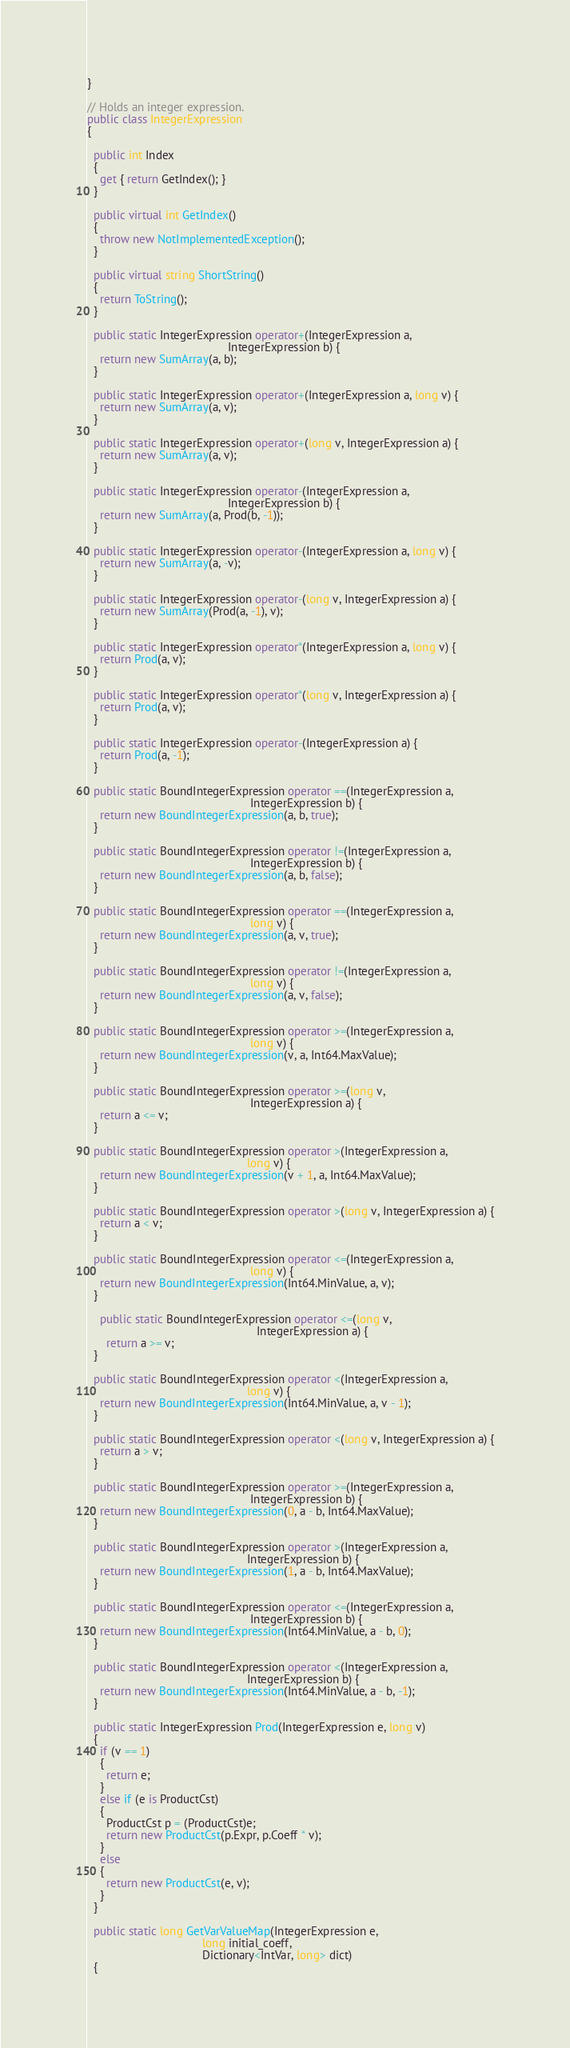Convert code to text. <code><loc_0><loc_0><loc_500><loc_500><_C#_>}

// Holds an integer expression.
public class IntegerExpression
{

  public int Index
  {
    get { return GetIndex(); }
  }

  public virtual int GetIndex()
  {
    throw new NotImplementedException();
  }

  public virtual string ShortString()
  {
    return ToString();
  }

  public static IntegerExpression operator+(IntegerExpression a,
                                            IntegerExpression b) {
    return new SumArray(a, b);
  }

  public static IntegerExpression operator+(IntegerExpression a, long v) {
    return new SumArray(a, v);
  }

  public static IntegerExpression operator+(long v, IntegerExpression a) {
    return new SumArray(a, v);
  }

  public static IntegerExpression operator-(IntegerExpression a,
                                            IntegerExpression b) {
    return new SumArray(a, Prod(b, -1));
  }

  public static IntegerExpression operator-(IntegerExpression a, long v) {
    return new SumArray(a, -v);
  }

  public static IntegerExpression operator-(long v, IntegerExpression a) {
    return new SumArray(Prod(a, -1), v);
  }

  public static IntegerExpression operator*(IntegerExpression a, long v) {
    return Prod(a, v);
  }

  public static IntegerExpression operator*(long v, IntegerExpression a) {
    return Prod(a, v);
  }

  public static IntegerExpression operator-(IntegerExpression a) {
    return Prod(a, -1);
  }

  public static BoundIntegerExpression operator ==(IntegerExpression a,
                                                   IntegerExpression b) {
    return new BoundIntegerExpression(a, b, true);
  }

  public static BoundIntegerExpression operator !=(IntegerExpression a,
                                                   IntegerExpression b) {
    return new BoundIntegerExpression(a, b, false);
  }

  public static BoundIntegerExpression operator ==(IntegerExpression a,
                                                   long v) {
    return new BoundIntegerExpression(a, v, true);
  }

  public static BoundIntegerExpression operator !=(IntegerExpression a,
                                                   long v) {
    return new BoundIntegerExpression(a, v, false);
  }

  public static BoundIntegerExpression operator >=(IntegerExpression a,
                                                   long v) {
    return new BoundIntegerExpression(v, a, Int64.MaxValue);
  }

  public static BoundIntegerExpression operator >=(long v,
                                                   IntegerExpression a) {
    return a <= v;
  }

  public static BoundIntegerExpression operator >(IntegerExpression a,
                                                  long v) {
    return new BoundIntegerExpression(v + 1, a, Int64.MaxValue);
  }

  public static BoundIntegerExpression operator >(long v, IntegerExpression a) {
    return a < v;
  }

  public static BoundIntegerExpression operator <=(IntegerExpression a,
                                                   long v) {
    return new BoundIntegerExpression(Int64.MinValue, a, v);
  }

    public static BoundIntegerExpression operator <=(long v,
                                                     IntegerExpression a) {
      return a >= v;
  }

  public static BoundIntegerExpression operator <(IntegerExpression a,
                                                  long v) {
    return new BoundIntegerExpression(Int64.MinValue, a, v - 1);
  }

  public static BoundIntegerExpression operator <(long v, IntegerExpression a) {
    return a > v;
  }

  public static BoundIntegerExpression operator >=(IntegerExpression a,
                                                   IntegerExpression b) {
    return new BoundIntegerExpression(0, a - b, Int64.MaxValue);
  }

  public static BoundIntegerExpression operator >(IntegerExpression a,
                                                  IntegerExpression b) {
    return new BoundIntegerExpression(1, a - b, Int64.MaxValue);
  }

  public static BoundIntegerExpression operator <=(IntegerExpression a,
                                                   IntegerExpression b) {
    return new BoundIntegerExpression(Int64.MinValue, a - b, 0);
  }

  public static BoundIntegerExpression operator <(IntegerExpression a,
                                                  IntegerExpression b) {
    return new BoundIntegerExpression(Int64.MinValue, a - b, -1);
  }

  public static IntegerExpression Prod(IntegerExpression e, long v)
  {
    if (v == 1)
    {
      return e;
    }
    else if (e is ProductCst)
    {
      ProductCst p = (ProductCst)e;
      return new ProductCst(p.Expr, p.Coeff * v);
    }
    else
    {
      return new ProductCst(e, v);
    }
  }

  public static long GetVarValueMap(IntegerExpression e,
                                    long initial_coeff,
                                    Dictionary<IntVar, long> dict)
  {</code> 